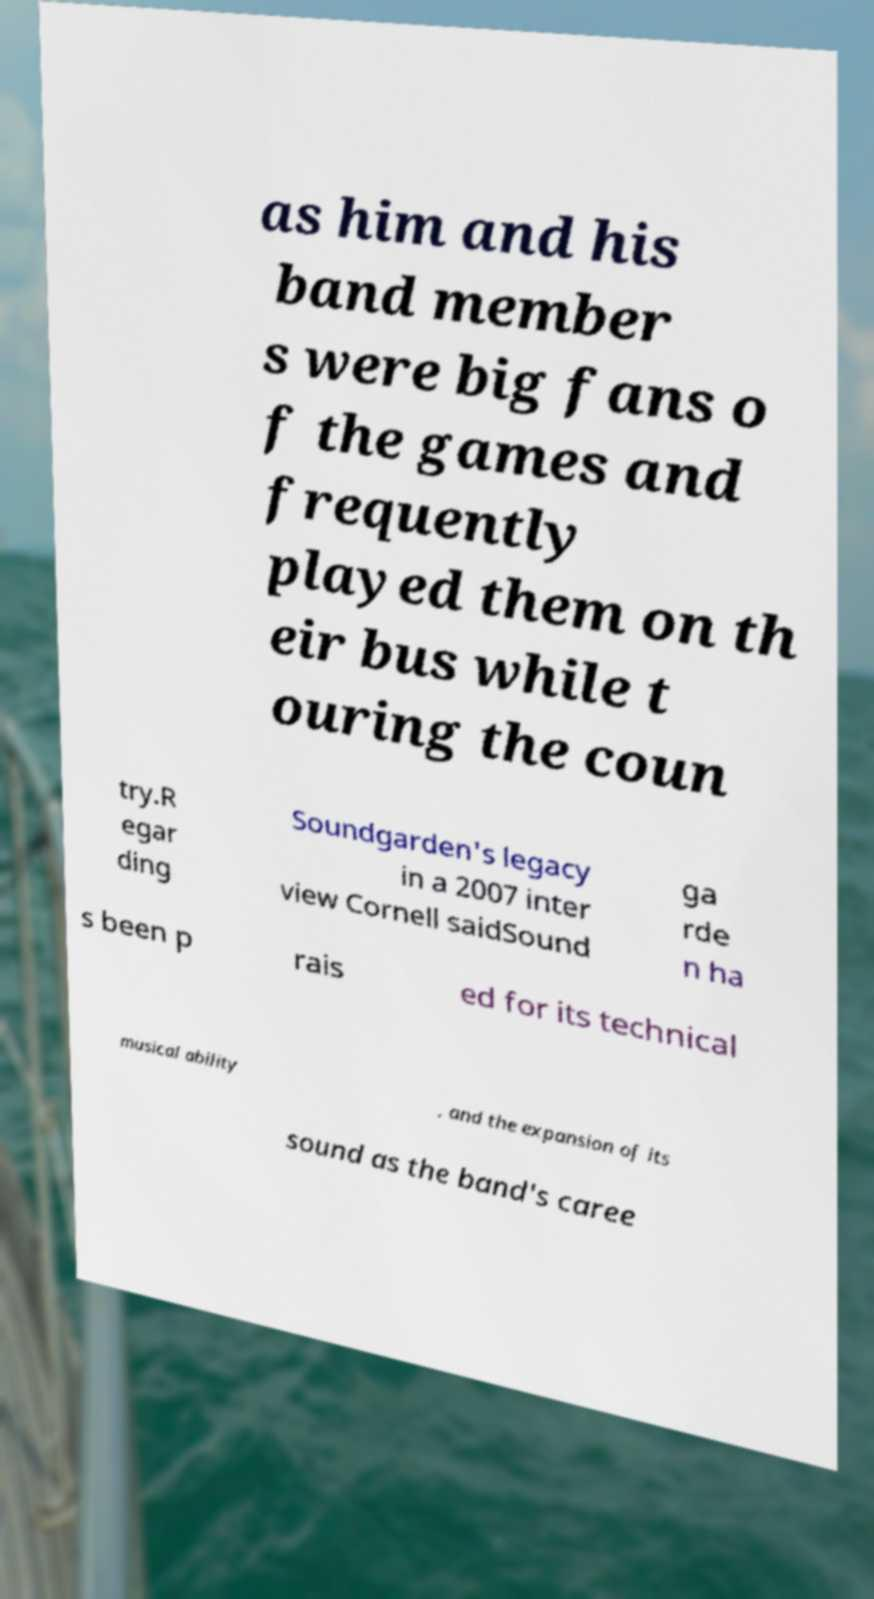Can you read and provide the text displayed in the image?This photo seems to have some interesting text. Can you extract and type it out for me? as him and his band member s were big fans o f the games and frequently played them on th eir bus while t ouring the coun try.R egar ding Soundgarden's legacy in a 2007 inter view Cornell saidSound ga rde n ha s been p rais ed for its technical musical ability , and the expansion of its sound as the band's caree 